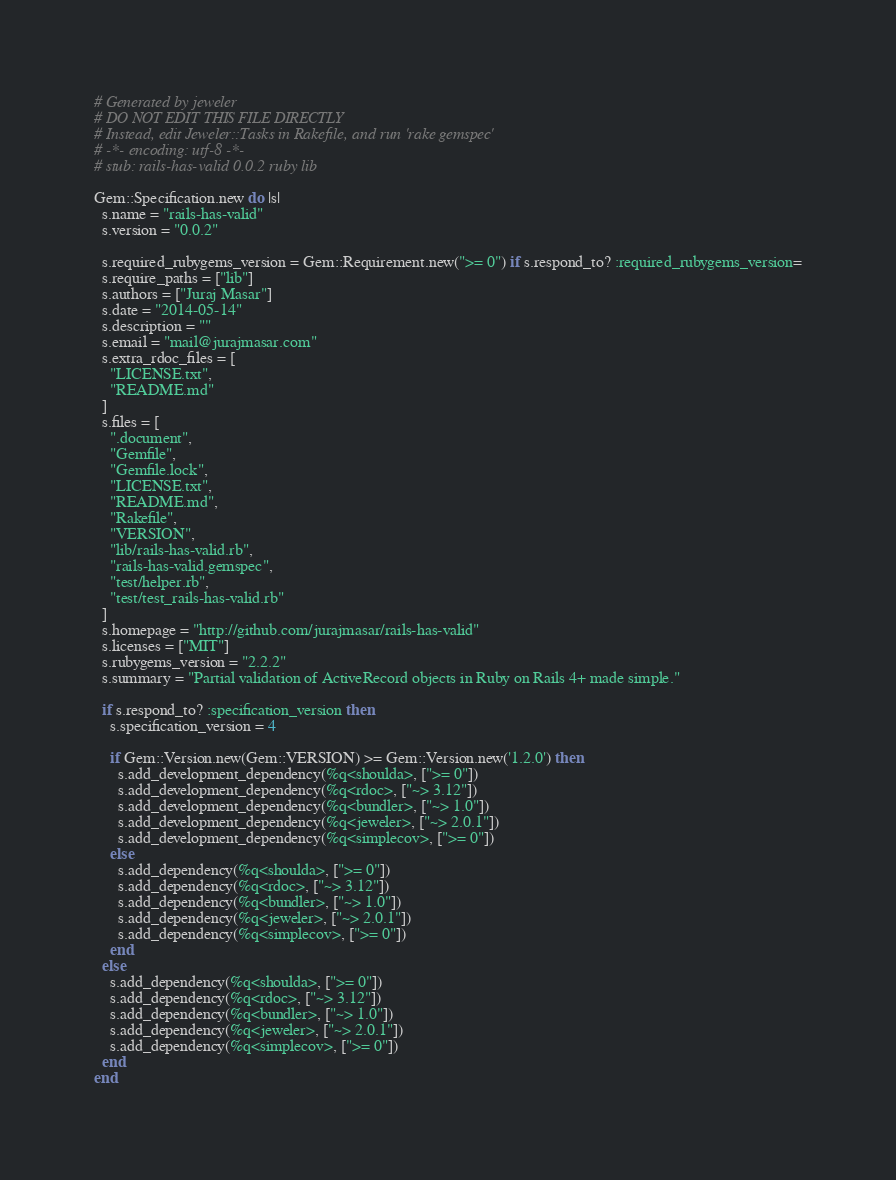Convert code to text. <code><loc_0><loc_0><loc_500><loc_500><_Ruby_># Generated by jeweler
# DO NOT EDIT THIS FILE DIRECTLY
# Instead, edit Jeweler::Tasks in Rakefile, and run 'rake gemspec'
# -*- encoding: utf-8 -*-
# stub: rails-has-valid 0.0.2 ruby lib

Gem::Specification.new do |s|
  s.name = "rails-has-valid"
  s.version = "0.0.2"

  s.required_rubygems_version = Gem::Requirement.new(">= 0") if s.respond_to? :required_rubygems_version=
  s.require_paths = ["lib"]
  s.authors = ["Juraj Masar"]
  s.date = "2014-05-14"
  s.description = ""
  s.email = "mail@jurajmasar.com"
  s.extra_rdoc_files = [
    "LICENSE.txt",
    "README.md"
  ]
  s.files = [
    ".document",
    "Gemfile",
    "Gemfile.lock",
    "LICENSE.txt",
    "README.md",
    "Rakefile",
    "VERSION",
    "lib/rails-has-valid.rb",
    "rails-has-valid.gemspec",
    "test/helper.rb",
    "test/test_rails-has-valid.rb"
  ]
  s.homepage = "http://github.com/jurajmasar/rails-has-valid"
  s.licenses = ["MIT"]
  s.rubygems_version = "2.2.2"
  s.summary = "Partial validation of ActiveRecord objects in Ruby on Rails 4+ made simple."

  if s.respond_to? :specification_version then
    s.specification_version = 4

    if Gem::Version.new(Gem::VERSION) >= Gem::Version.new('1.2.0') then
      s.add_development_dependency(%q<shoulda>, [">= 0"])
      s.add_development_dependency(%q<rdoc>, ["~> 3.12"])
      s.add_development_dependency(%q<bundler>, ["~> 1.0"])
      s.add_development_dependency(%q<jeweler>, ["~> 2.0.1"])
      s.add_development_dependency(%q<simplecov>, [">= 0"])
    else
      s.add_dependency(%q<shoulda>, [">= 0"])
      s.add_dependency(%q<rdoc>, ["~> 3.12"])
      s.add_dependency(%q<bundler>, ["~> 1.0"])
      s.add_dependency(%q<jeweler>, ["~> 2.0.1"])
      s.add_dependency(%q<simplecov>, [">= 0"])
    end
  else
    s.add_dependency(%q<shoulda>, [">= 0"])
    s.add_dependency(%q<rdoc>, ["~> 3.12"])
    s.add_dependency(%q<bundler>, ["~> 1.0"])
    s.add_dependency(%q<jeweler>, ["~> 2.0.1"])
    s.add_dependency(%q<simplecov>, [">= 0"])
  end
end

</code> 